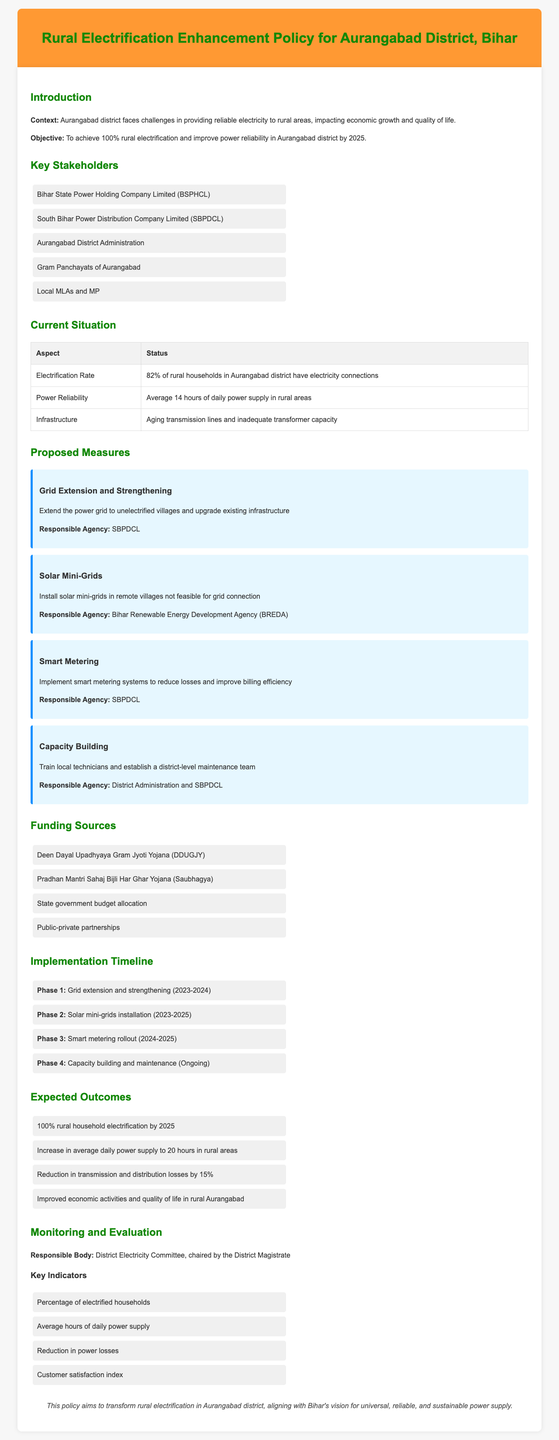What is the objective of the policy? The objective is to achieve 100% rural electrification and improve power reliability in Aurangabad district by 2025.
Answer: 100% rural electrification by 2025 What is the current electrification rate? The electrification rate is specified in the document as the percentage of rural households with electricity connections.
Answer: 82% Who is responsible for grid extension and strengthening? The document specifies which agency is responsible for each proposed measure, and for grid extension, it mentions SBPDCL.
Answer: SBPDCL How many phases are included in the implementation timeline? The implementation timeline outlines several phases, and the specific number can be directly identified in the document.
Answer: 4 What is the expected increase in average daily power supply? The expected average daily power supply increase is stated in the outcomes section and can be directly retrieved from the information given.
Answer: 20 hours What funding source is related to rural electricity initiatives? Several funding sources are listed in the document, and one of them addresses rural electrification support.
Answer: Deen Dayal Upadhyaya Gram Jyoti Yojana (DDUGJY) How often will capacity building occur? The document outlines the ongoing nature of a specific phase in the implementation timeline, indicating the frequency of capacity building efforts.
Answer: Ongoing Who chairs the monitoring body? The responsible body for monitoring is specified along with its chairperson in the document.
Answer: District Magistrate What is one of the key indicators for evaluation? The document lists several indicators for evaluation, and answering this would mention a specific one from that list.
Answer: Percentage of electrified households 